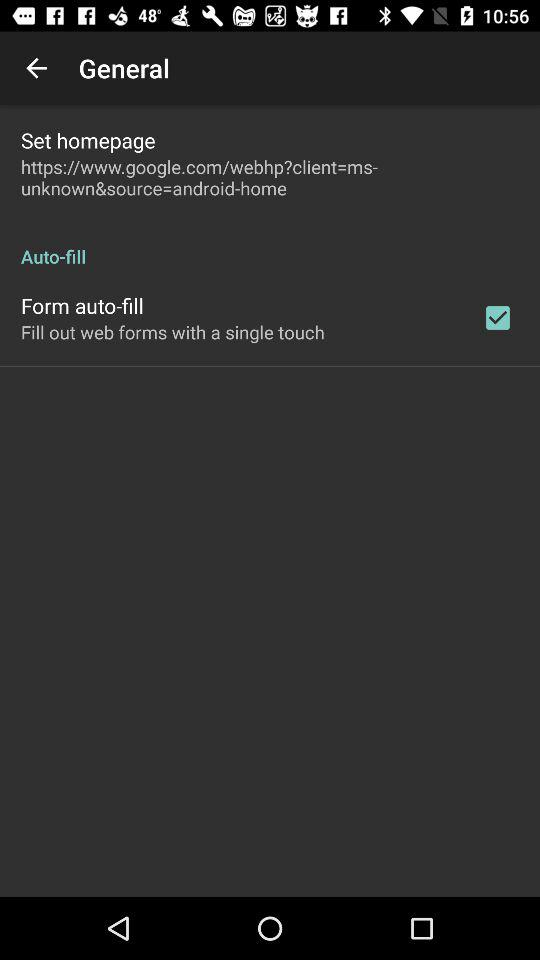What's the status for the "Form auto-fill"? The status for the "Form auto-fill" is "on". 